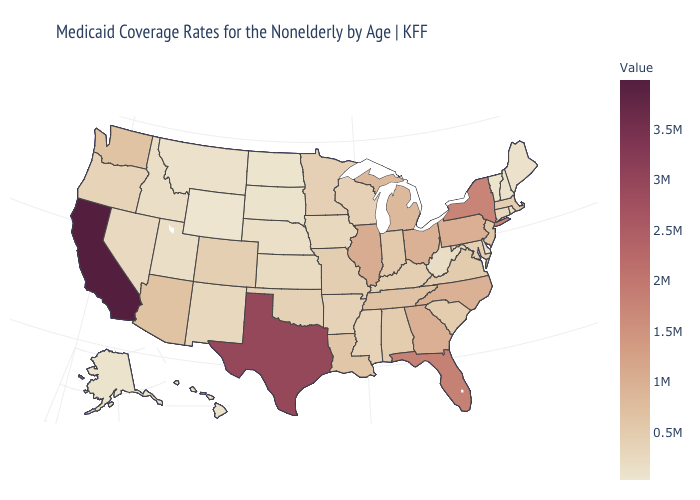Among the states that border Connecticut , which have the lowest value?
Write a very short answer. Rhode Island. Among the states that border Louisiana , does Mississippi have the highest value?
Short answer required. No. Which states hav the highest value in the MidWest?
Be succinct. Illinois. Among the states that border Kentucky , does Virginia have the lowest value?
Be succinct. No. Which states have the lowest value in the South?
Answer briefly. Delaware. Does the map have missing data?
Quick response, please. No. Among the states that border Wyoming , does South Dakota have the highest value?
Be succinct. No. 